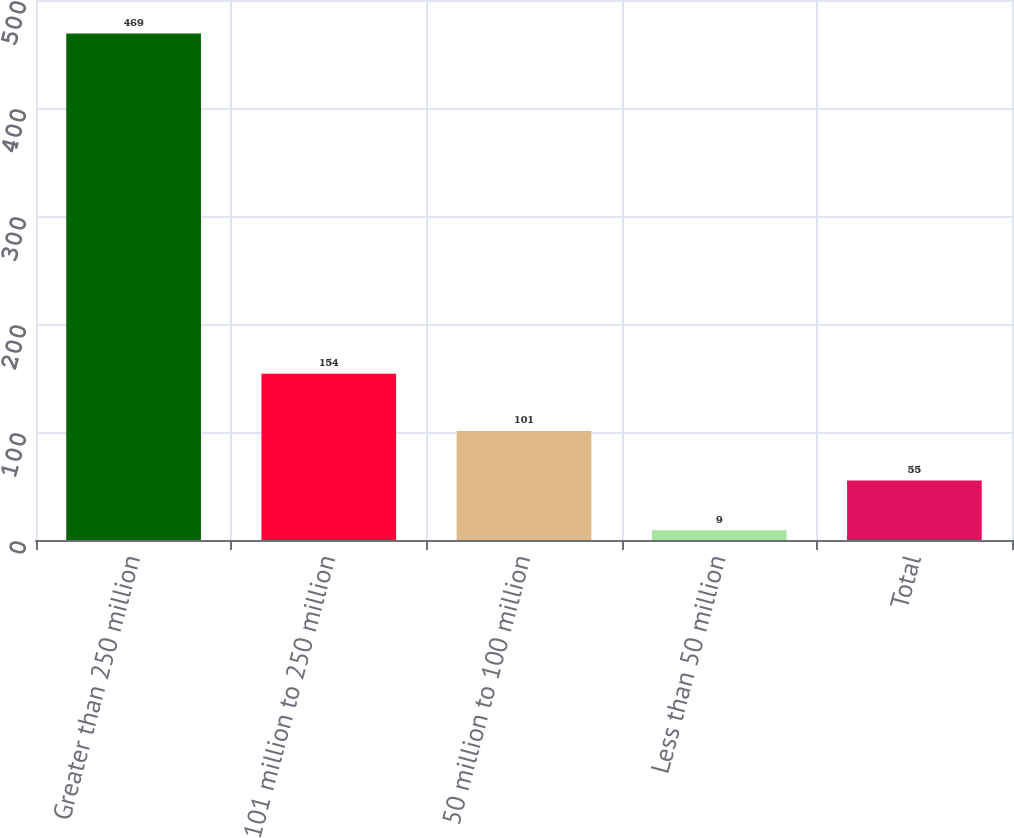Convert chart to OTSL. <chart><loc_0><loc_0><loc_500><loc_500><bar_chart><fcel>Greater than 250 million<fcel>101 million to 250 million<fcel>50 million to 100 million<fcel>Less than 50 million<fcel>Total<nl><fcel>469<fcel>154<fcel>101<fcel>9<fcel>55<nl></chart> 